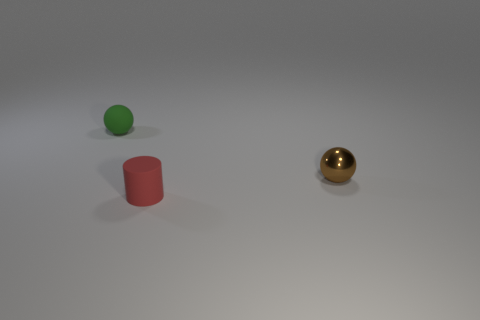Subtract 2 balls. How many balls are left? 0 Add 2 tiny green balls. How many objects exist? 5 Subtract all balls. How many objects are left? 1 Add 1 cylinders. How many cylinders are left? 2 Add 3 small green matte spheres. How many small green matte spheres exist? 4 Subtract 0 brown cylinders. How many objects are left? 3 Subtract all cyan spheres. Subtract all cyan cubes. How many spheres are left? 2 Subtract all red blocks. How many gray spheres are left? 0 Subtract all small rubber objects. Subtract all big cyan cylinders. How many objects are left? 1 